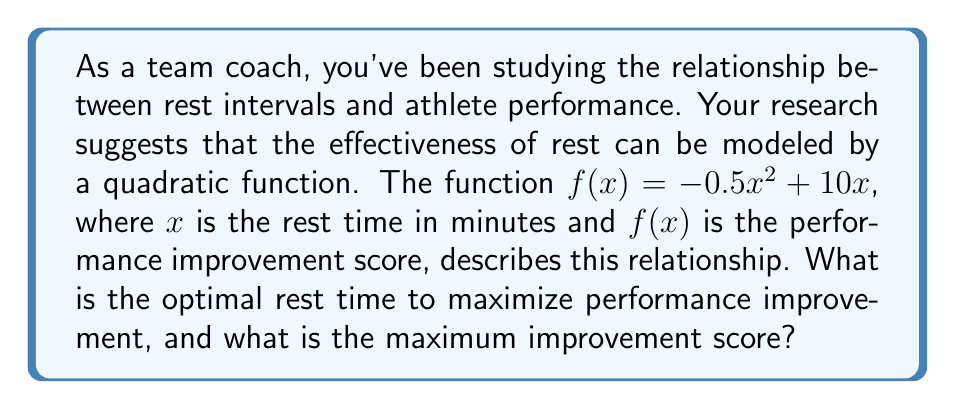Teach me how to tackle this problem. To solve this problem, we need to find the vertex of the quadratic function, as it represents the maximum point of the parabola.

1) The quadratic function is in the form $f(x) = ax^2 + bx + c$, where:
   $a = -0.5$, $b = 10$, and $c = 0$

2) For a quadratic function, the x-coordinate of the vertex is given by $x = -\frac{b}{2a}$

3) Substituting our values:
   $x = -\frac{10}{2(-0.5)} = -\frac{10}{-1} = 10$

4) So, the optimal rest time is 10 minutes.

5) To find the maximum improvement score, we need to calculate $f(10)$:
   $f(10) = -0.5(10)^2 + 10(10)$
   $f(10) = -0.5(100) + 100$
   $f(10) = -50 + 100 = 50$

Therefore, the maximum improvement score is 50.

We can verify this is indeed the maximum by testing values on either side of $x = 10$:

$f(9) = -0.5(9)^2 + 10(9) = -40.5 + 90 = 49.5$
$f(11) = -0.5(11)^2 + 10(11) = -60.5 + 110 = 49.5$

Both of these values are less than $f(10) = 50$, confirming that 10 minutes is indeed the optimal rest time.
Answer: The optimal rest time is 10 minutes, and the maximum improvement score is 50. 